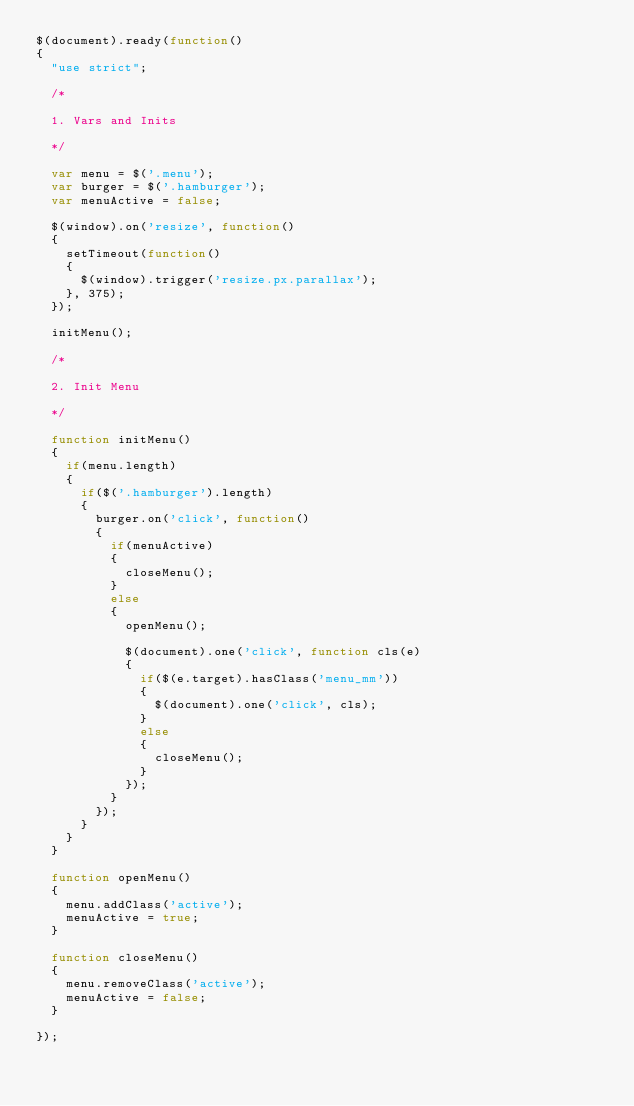<code> <loc_0><loc_0><loc_500><loc_500><_JavaScript_>$(document).ready(function()
{
	"use strict";

	/* 

	1. Vars and Inits

	*/

	var menu = $('.menu');
	var burger = $('.hamburger');
	var menuActive = false;

	$(window).on('resize', function()
	{
		setTimeout(function()
		{
			$(window).trigger('resize.px.parallax');
		}, 375);
	});

	initMenu();

	/* 

	2. Init Menu

	*/

	function initMenu()
	{
		if(menu.length)
		{
			if($('.hamburger').length)
			{
				burger.on('click', function()
				{
					if(menuActive)
					{
						closeMenu();
					}
					else
					{
						openMenu();

						$(document).one('click', function cls(e)
						{
							if($(e.target).hasClass('menu_mm'))
							{
								$(document).one('click', cls);
							}
							else
							{
								closeMenu();
							}
						});
					}
				});
			}
		}
	}

	function openMenu()
	{
		menu.addClass('active');
		menuActive = true;
	}

	function closeMenu()
	{
		menu.removeClass('active');
		menuActive = false;
	}

});
</code> 